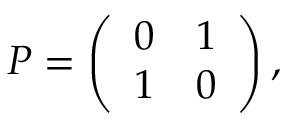<formula> <loc_0><loc_0><loc_500><loc_500>\begin{array} { r } { P = \left ( \begin{array} { l l } { 0 } & { 1 } \\ { 1 } & { 0 } \end{array} \right ) , } \end{array}</formula> 